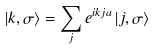Convert formula to latex. <formula><loc_0><loc_0><loc_500><loc_500>\left | k , \sigma \right \rangle = \sum _ { j } e ^ { i k j a } \left | j , \sigma \right \rangle</formula> 